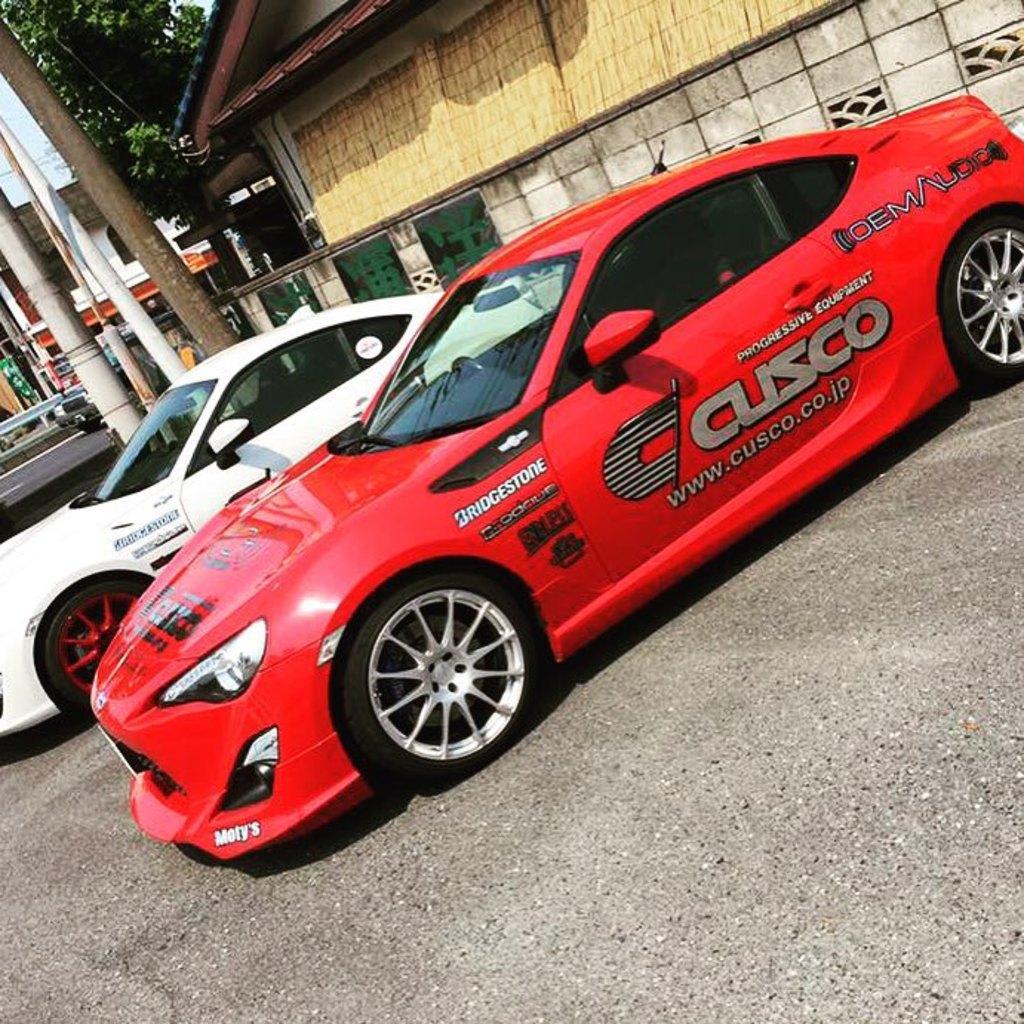In one or two sentences, can you explain what this image depicts? At the bottom of the image on the ground there are cars. Behind them there is a wall. Behind the wall there is a house. In the background there are trees, poles and some other things in the background. 